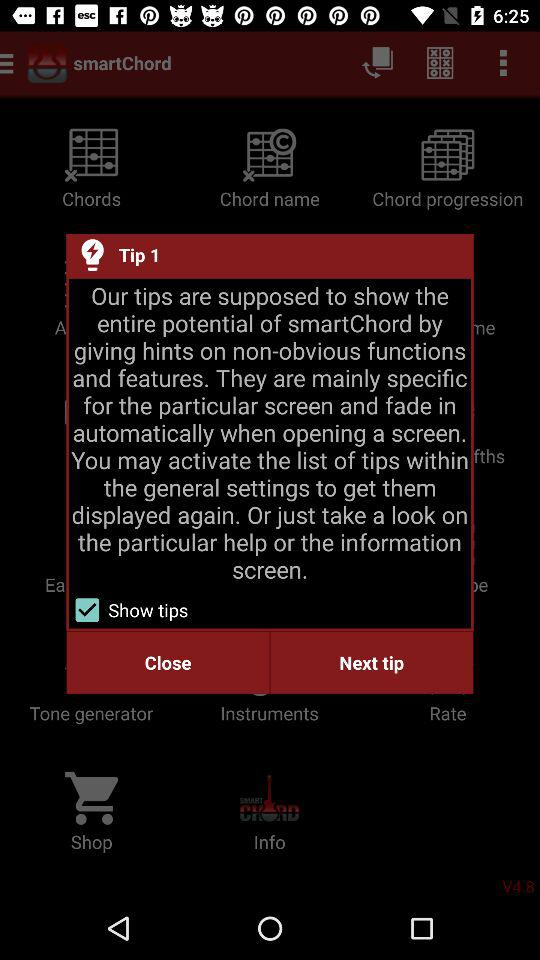How many tips are available?
Answer the question using a single word or phrase. 1 